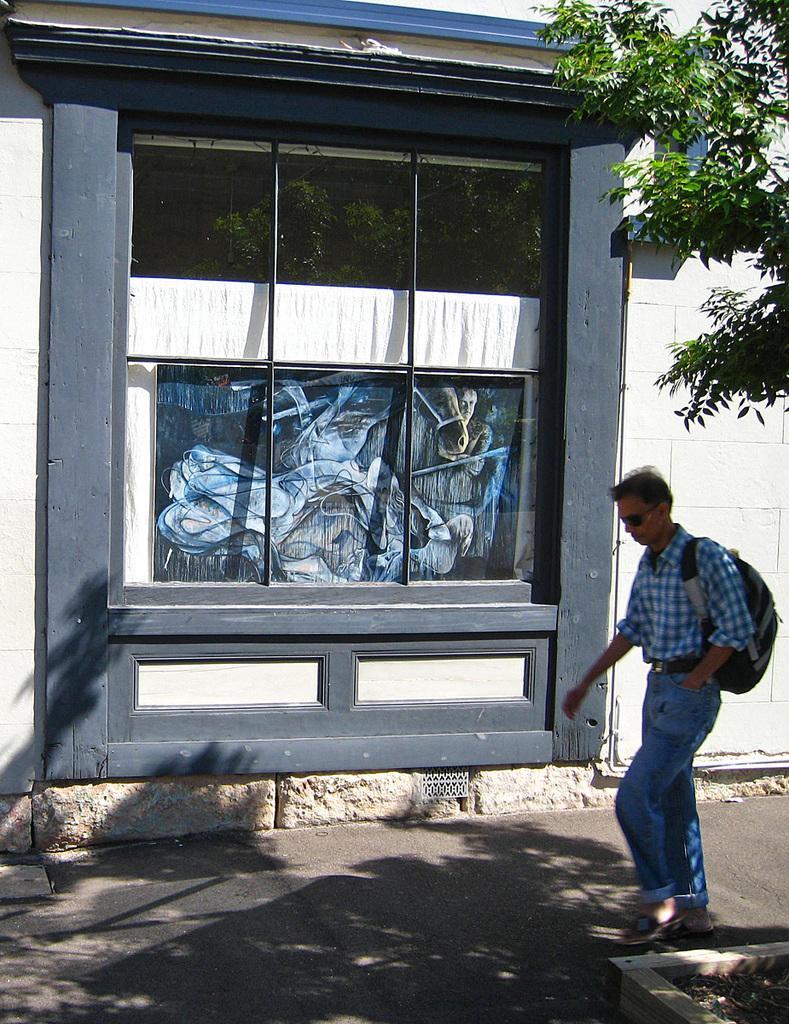How would you summarize this image in a sentence or two? In this image in the front there is a person walking on the road and on the right side there are leaves. In the background there is a wall and there is a window and behind the window there is a painting and there is a curtain which is white in colour. 